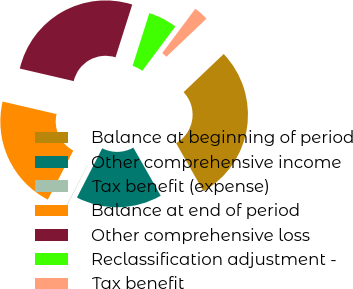<chart> <loc_0><loc_0><loc_500><loc_500><pie_chart><fcel>Balance at beginning of period<fcel>Other comprehensive income<fcel>Tax benefit (expense)<fcel>Balance at end of period<fcel>Other comprehensive loss<fcel>Reclassification adjustment -<fcel>Tax benefit<nl><fcel>28.86%<fcel>15.78%<fcel>0.08%<fcel>21.01%<fcel>26.25%<fcel>5.31%<fcel>2.7%<nl></chart> 